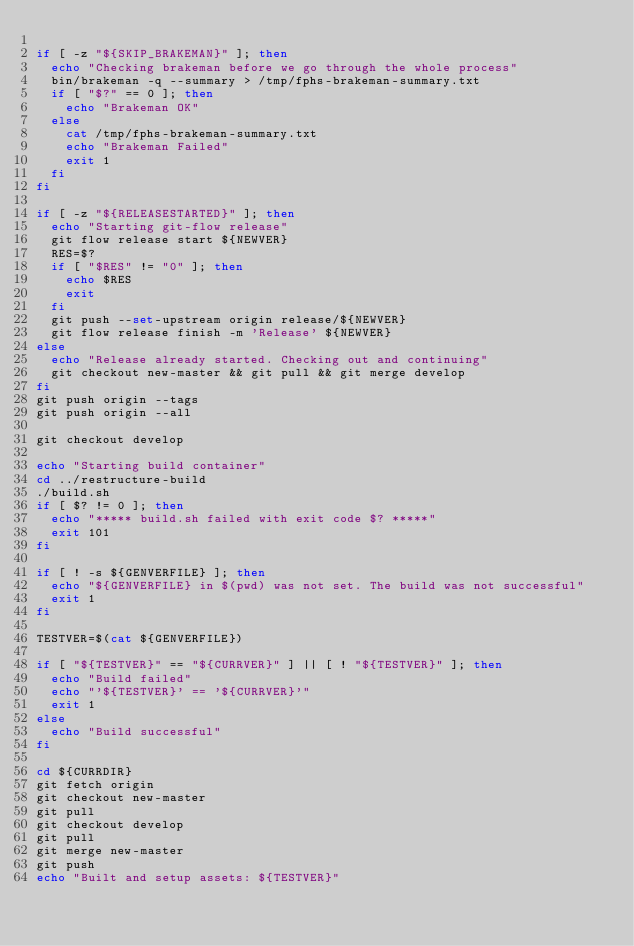<code> <loc_0><loc_0><loc_500><loc_500><_Bash_>
if [ -z "${SKIP_BRAKEMAN}" ]; then
  echo "Checking brakeman before we go through the whole process"
  bin/brakeman -q --summary > /tmp/fphs-brakeman-summary.txt
  if [ "$?" == 0 ]; then
    echo "Brakeman OK"
  else
    cat /tmp/fphs-brakeman-summary.txt
    echo "Brakeman Failed"
    exit 1
  fi
fi

if [ -z "${RELEASESTARTED}" ]; then
  echo "Starting git-flow release"
  git flow release start ${NEWVER}
  RES=$?
  if [ "$RES" != "0" ]; then
    echo $RES
    exit
  fi
  git push --set-upstream origin release/${NEWVER}
  git flow release finish -m 'Release' ${NEWVER}
else
  echo "Release already started. Checking out and continuing"
  git checkout new-master && git pull && git merge develop
fi
git push origin --tags
git push origin --all

git checkout develop

echo "Starting build container"
cd ../restructure-build
./build.sh
if [ $? != 0 ]; then
  echo "***** build.sh failed with exit code $? *****"
  exit 101
fi

if [ ! -s ${GENVERFILE} ]; then
  echo "${GENVERFILE} in $(pwd) was not set. The build was not successful"
  exit 1
fi

TESTVER=$(cat ${GENVERFILE})

if [ "${TESTVER}" == "${CURRVER}" ] || [ ! "${TESTVER}" ]; then
  echo "Build failed"
  echo "'${TESTVER}' == '${CURRVER}'"
  exit 1
else
  echo "Build successful"
fi

cd ${CURRDIR}
git fetch origin
git checkout new-master
git pull
git checkout develop
git pull
git merge new-master
git push
echo "Built and setup assets: ${TESTVER}"
</code> 